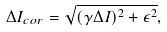Convert formula to latex. <formula><loc_0><loc_0><loc_500><loc_500>\Delta I _ { c o r } = \sqrt { ( \gamma \Delta I ) ^ { 2 } + \epsilon ^ { 2 } } ,</formula> 